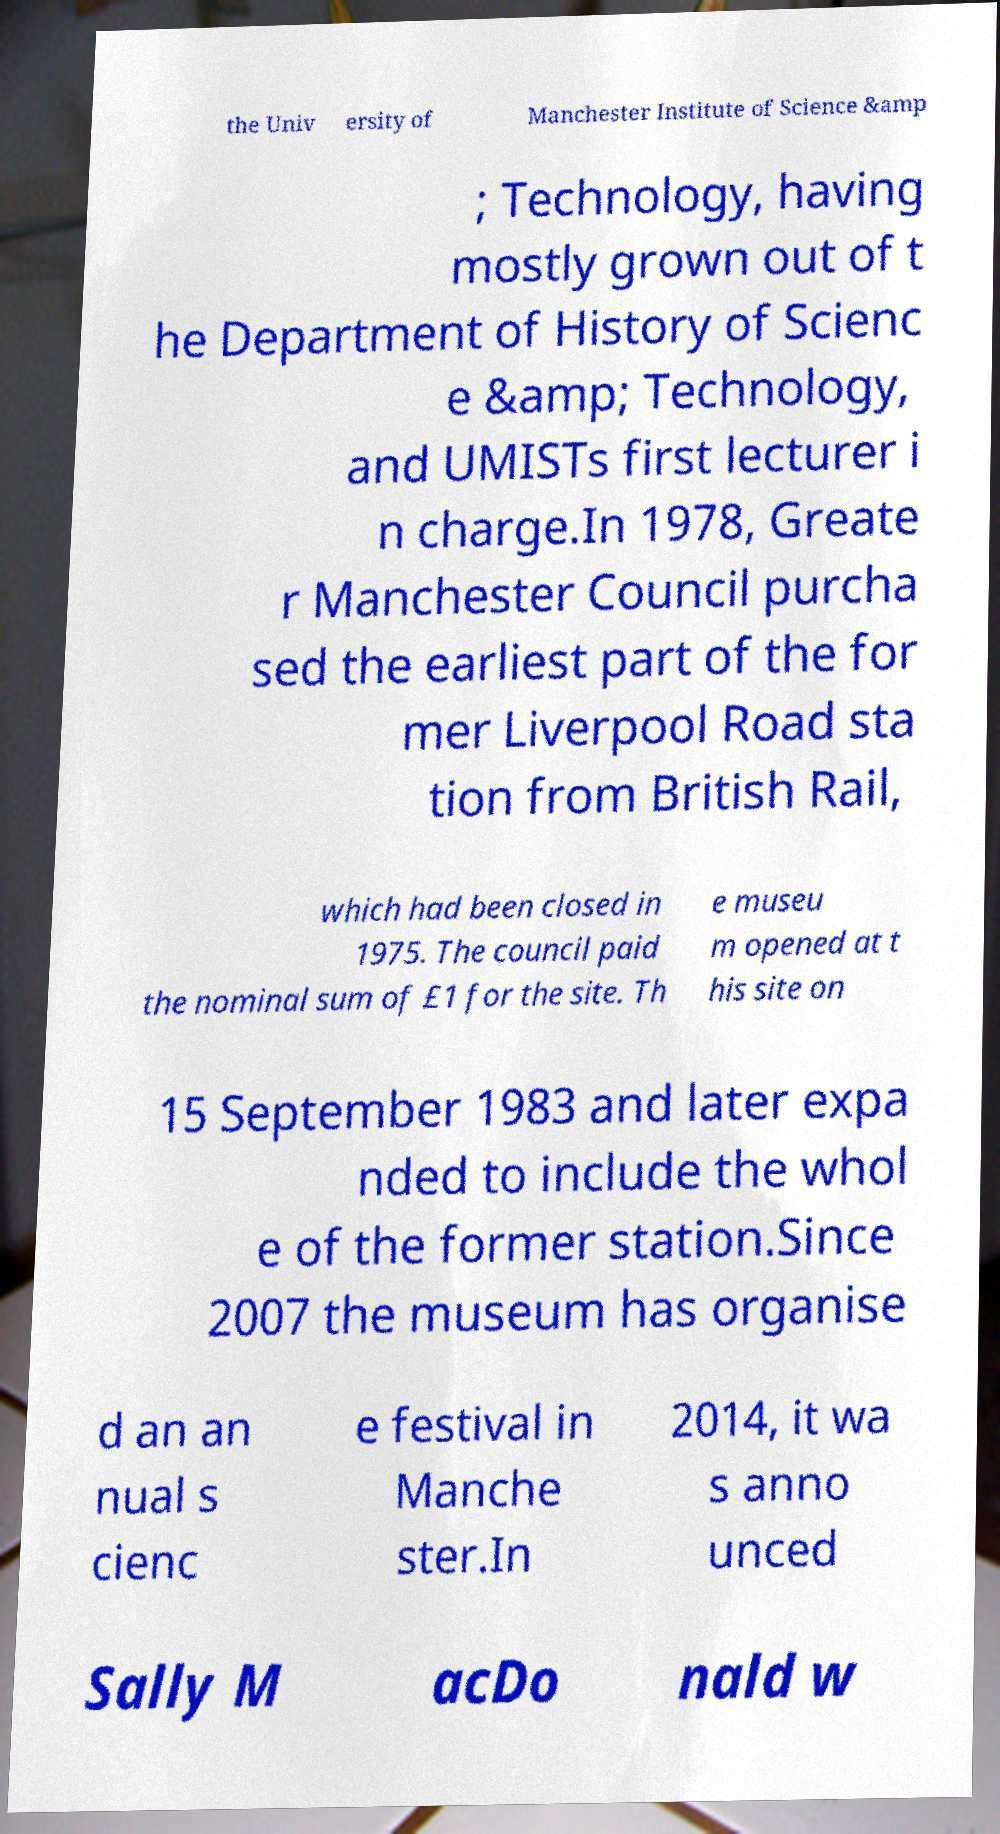Could you extract and type out the text from this image? the Univ ersity of Manchester Institute of Science &amp ; Technology, having mostly grown out of t he Department of History of Scienc e &amp; Technology, and UMISTs first lecturer i n charge.In 1978, Greate r Manchester Council purcha sed the earliest part of the for mer Liverpool Road sta tion from British Rail, which had been closed in 1975. The council paid the nominal sum of £1 for the site. Th e museu m opened at t his site on 15 September 1983 and later expa nded to include the whol e of the former station.Since 2007 the museum has organise d an an nual s cienc e festival in Manche ster.In 2014, it wa s anno unced Sally M acDo nald w 